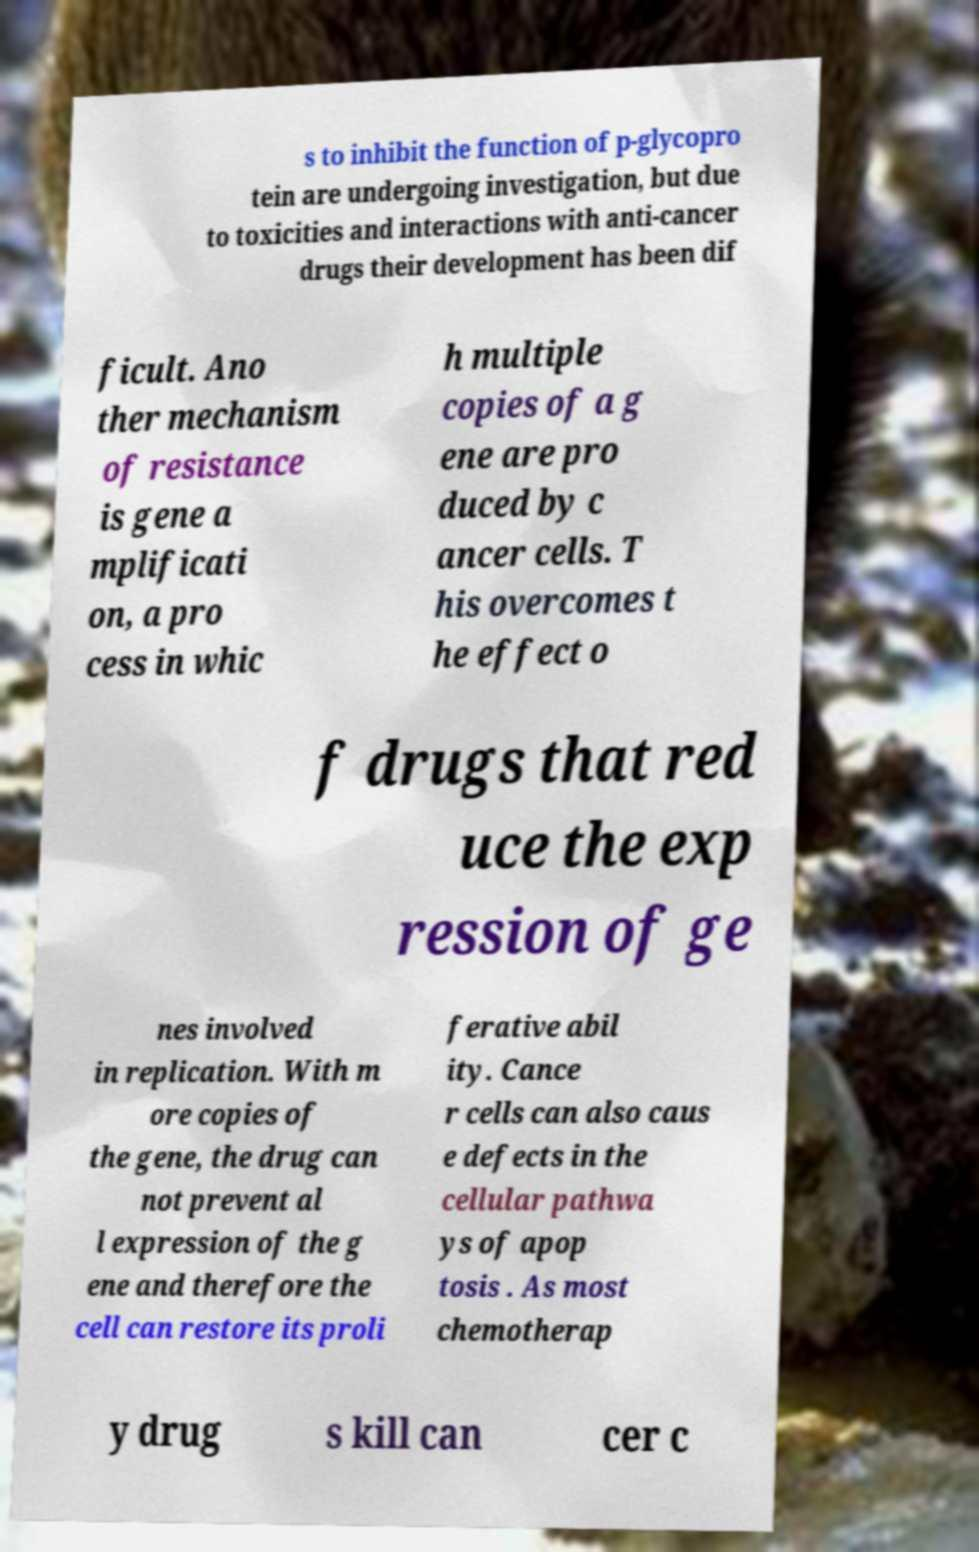Could you extract and type out the text from this image? s to inhibit the function of p-glycopro tein are undergoing investigation, but due to toxicities and interactions with anti-cancer drugs their development has been dif ficult. Ano ther mechanism of resistance is gene a mplificati on, a pro cess in whic h multiple copies of a g ene are pro duced by c ancer cells. T his overcomes t he effect o f drugs that red uce the exp ression of ge nes involved in replication. With m ore copies of the gene, the drug can not prevent al l expression of the g ene and therefore the cell can restore its proli ferative abil ity. Cance r cells can also caus e defects in the cellular pathwa ys of apop tosis . As most chemotherap y drug s kill can cer c 